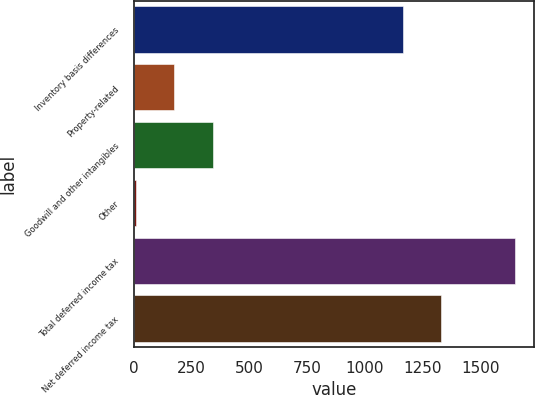Convert chart. <chart><loc_0><loc_0><loc_500><loc_500><bar_chart><fcel>Inventory basis differences<fcel>Property-related<fcel>Goodwill and other intangibles<fcel>Other<fcel>Total deferred income tax<fcel>Net deferred income tax<nl><fcel>1164<fcel>171.6<fcel>340<fcel>7<fcel>1653<fcel>1328.6<nl></chart> 